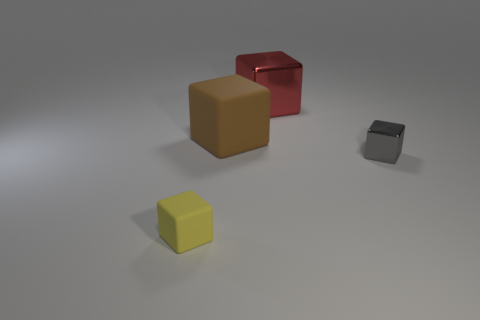Subtract all big red blocks. How many blocks are left? 3 Add 1 tiny blocks. How many objects exist? 5 Subtract all gray cylinders. How many cyan blocks are left? 0 Subtract all yellow matte cylinders. Subtract all large red cubes. How many objects are left? 3 Add 2 tiny gray things. How many tiny gray things are left? 3 Add 3 metal blocks. How many metal blocks exist? 5 Subtract all yellow blocks. How many blocks are left? 3 Subtract 0 cyan blocks. How many objects are left? 4 Subtract 3 blocks. How many blocks are left? 1 Subtract all purple cubes. Subtract all cyan spheres. How many cubes are left? 4 